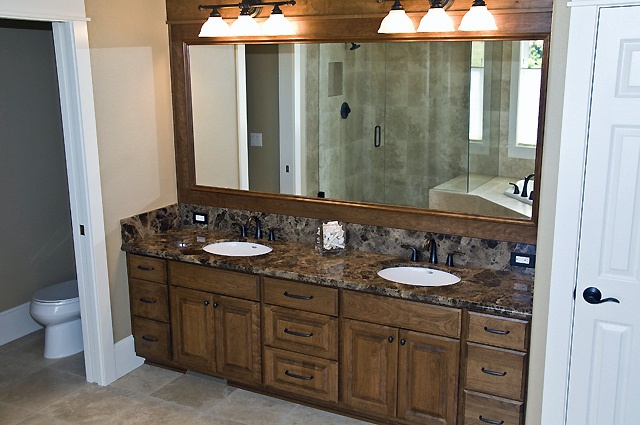Describe the objects in this image and their specific colors. I can see toilet in lightgray, darkgray, and gray tones, sink in lightgray, gray, black, and darkgray tones, and sink in lightgray, black, and gray tones in this image. 